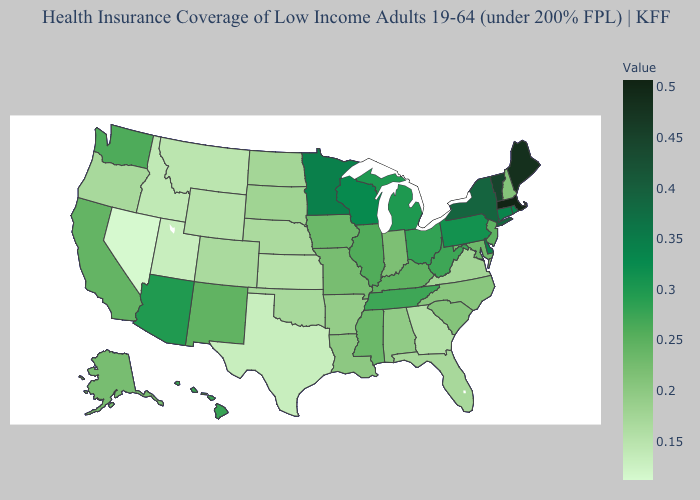Does Maine have the highest value in the Northeast?
Be succinct. No. Does Florida have a higher value than Nevada?
Quick response, please. Yes. Does Arizona have the highest value in the West?
Quick response, please. Yes. Does Massachusetts have the highest value in the USA?
Short answer required. Yes. Which states have the lowest value in the USA?
Give a very brief answer. Nevada. Does Delaware have the highest value in the South?
Write a very short answer. Yes. Does Nevada have the lowest value in the West?
Answer briefly. Yes. Does South Dakota have the highest value in the USA?
Write a very short answer. No. 